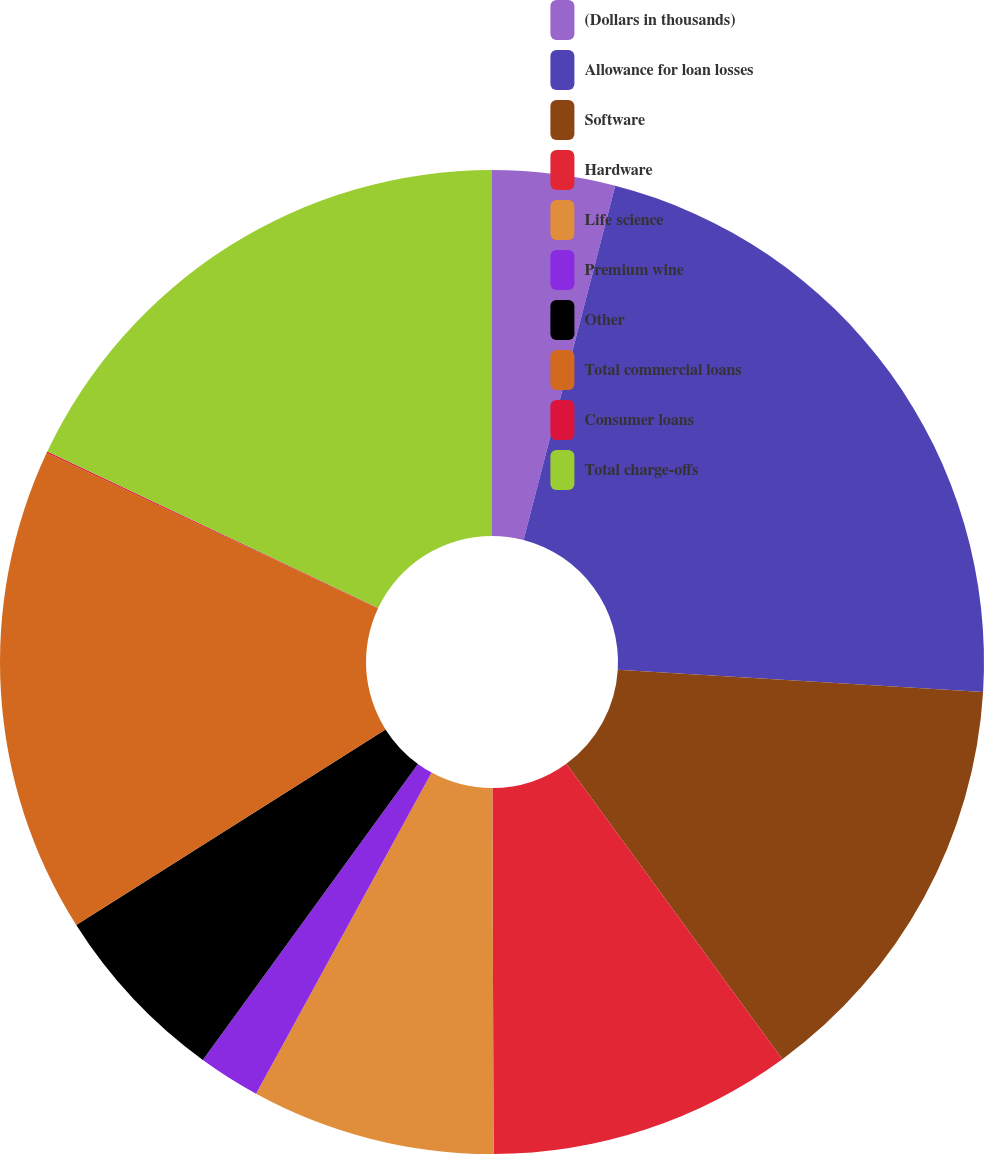Convert chart to OTSL. <chart><loc_0><loc_0><loc_500><loc_500><pie_chart><fcel>(Dollars in thousands)<fcel>Allowance for loan losses<fcel>Software<fcel>Hardware<fcel>Life science<fcel>Premium wine<fcel>Other<fcel>Total commercial loans<fcel>Consumer loans<fcel>Total charge-offs<nl><fcel>4.03%<fcel>21.94%<fcel>13.98%<fcel>10.0%<fcel>8.01%<fcel>2.04%<fcel>6.02%<fcel>15.97%<fcel>0.05%<fcel>17.96%<nl></chart> 